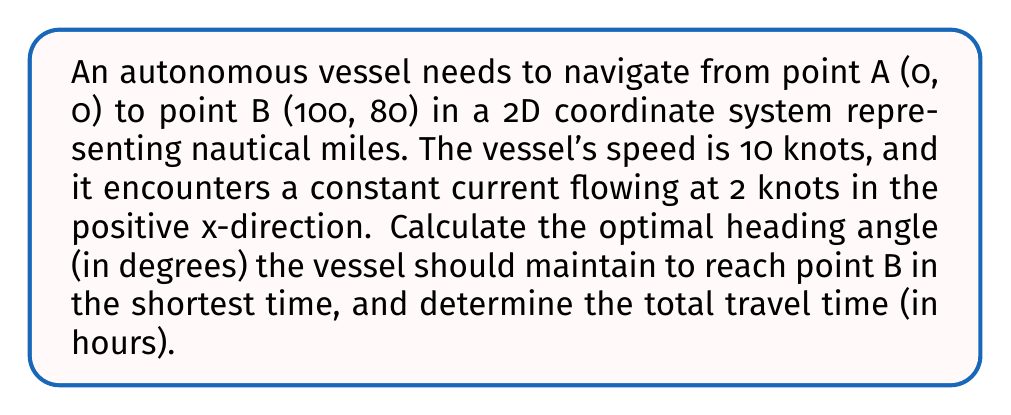Could you help me with this problem? 1. Let's define the variables:
   $\theta$ = heading angle (to be determined)
   $v$ = vessel speed = 10 knots
   $c$ = current speed = 2 knots

2. The vessel's velocity components considering the current:
   $v_x = v \cos(\theta) + c$
   $v_y = v \sin(\theta)$

3. Time to reach point B:
   $t = \frac{\sqrt{100^2 + 80^2}}{v_{eff}}$, where $v_{eff}$ is the effective velocity towards B.

4. To minimize time, we need to maximize $v_{eff}$:
   $v_{eff} = \frac{100v_x + 80v_y}{\sqrt{100^2 + 80^2}}$

5. Substitute the expressions for $v_x$ and $v_y$:
   $v_{eff} = \frac{100(v \cos(\theta) + c) + 80v \sin(\theta)}{\sqrt{100^2 + 80^2}}$

6. To find the optimal $\theta$, differentiate $v_{eff}$ with respect to $\theta$ and set it to zero:
   $\frac{d v_{eff}}{d \theta} = \frac{-100v \sin(\theta) + 80v \cos(\theta)}{\sqrt{100^2 + 80^2}} = 0$

7. Solve for $\theta$:
   $\tan(\theta) = \frac{80}{100} = 0.8$
   $\theta = \arctan(0.8) \approx 38.66°$

8. Calculate the effective velocity:
   $v_{eff} = \frac{100(10 \cos(38.66°) + 2) + 80(10 \sin(38.66°))}{\sqrt{100^2 + 80^2}} \approx 11.18$ knots

9. Calculate the total travel time:
   $t = \frac{\sqrt{100^2 + 80^2}}{11.18} \approx 11.36$ hours
Answer: Optimal heading angle: 38.66°; Total travel time: 11.36 hours 